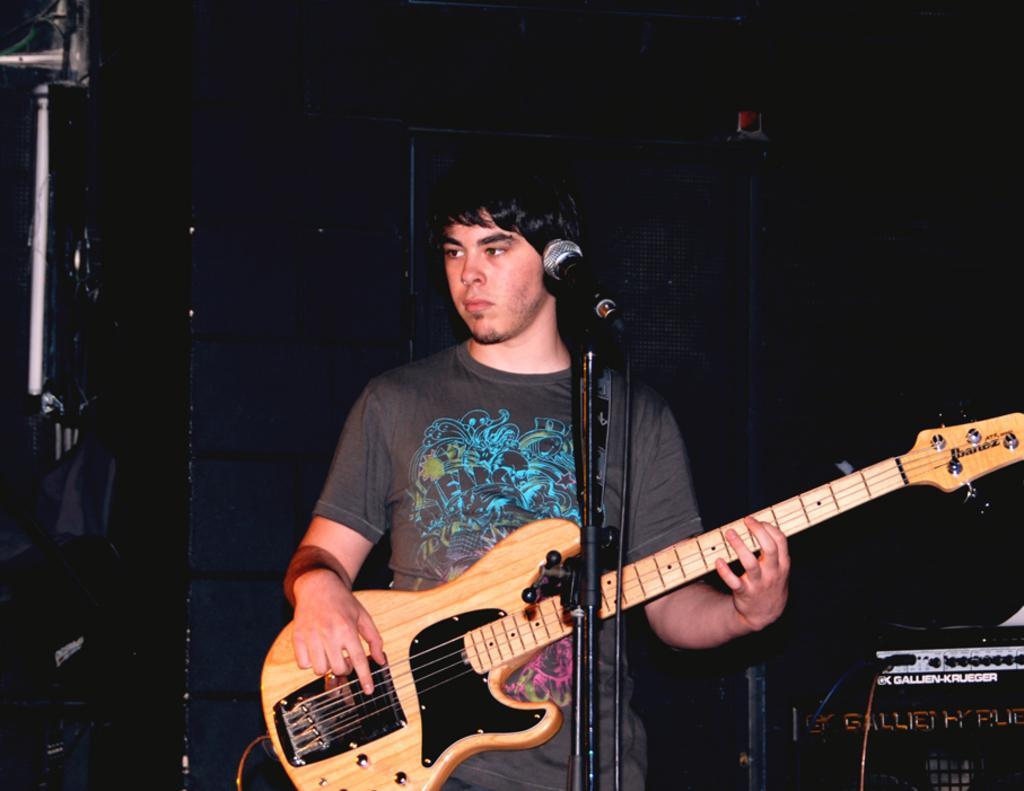Please provide a concise description of this image. In the middle of the image a man is holding a guitar. In the middle of the image there is a microphone. Bottom right side of the image there is a electronic device. 